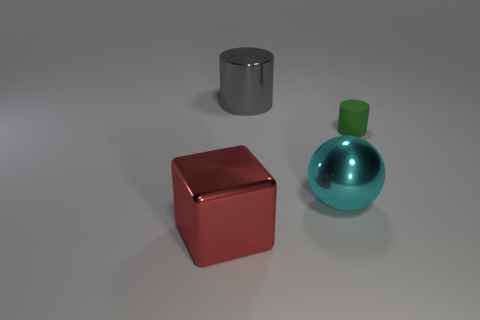There is a large metallic object that is behind the rubber cylinder; does it have the same shape as the green object?
Ensure brevity in your answer.  Yes. What number of objects are both behind the big red metallic cube and to the left of the large gray shiny thing?
Offer a terse response. 0. What is the small green cylinder made of?
Give a very brief answer. Rubber. Is there any other thing of the same color as the rubber thing?
Your answer should be compact. No. Does the big cylinder have the same material as the big ball?
Your answer should be very brief. Yes. There is a big shiny thing that is behind the green object that is in front of the big gray cylinder; what number of rubber cylinders are left of it?
Your answer should be compact. 0. What number of large blue shiny cylinders are there?
Provide a short and direct response. 0. Is the number of objects to the right of the cyan object less than the number of small matte objects that are behind the big gray cylinder?
Offer a very short reply. No. Are there fewer cyan metal objects that are behind the green rubber cylinder than purple matte cubes?
Offer a terse response. No. What is the large thing that is behind the large object that is to the right of the thing behind the small matte cylinder made of?
Ensure brevity in your answer.  Metal. 